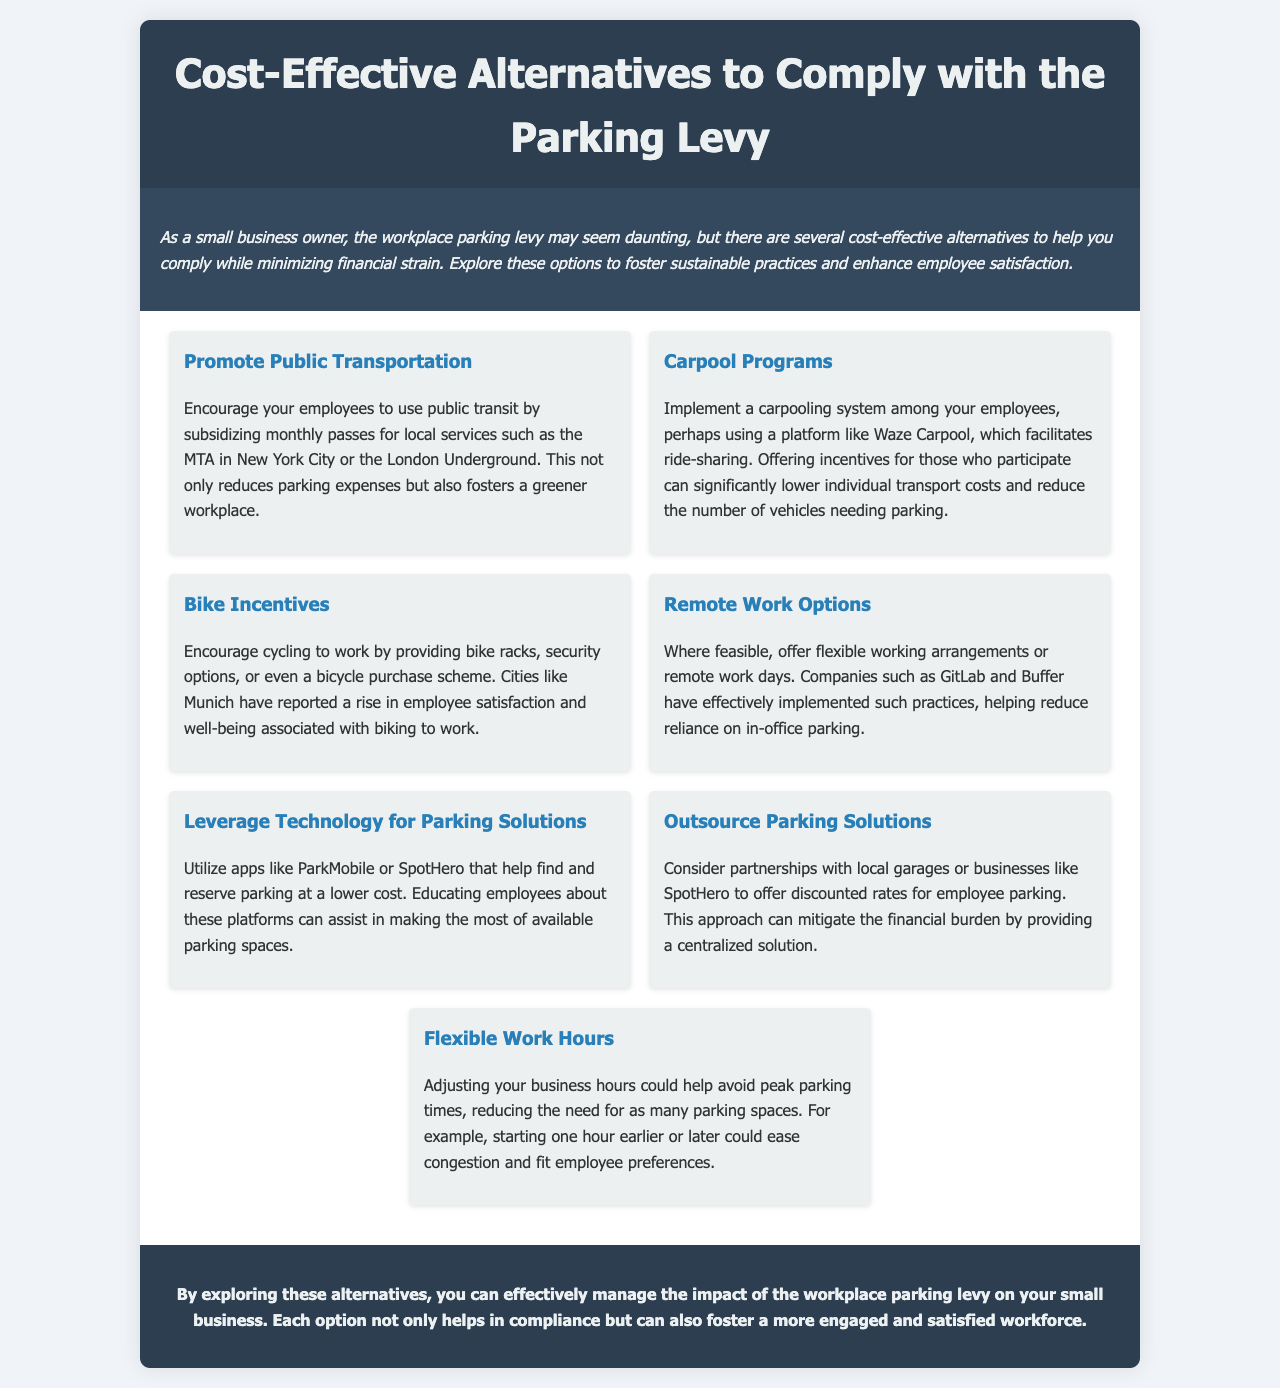What is the title of the brochure? The title is prominently displayed at the top of the document, identifying the key subject of the content.
Answer: Cost-Effective Alternatives to Comply with the Parking Levy Who is the target audience of the brochure? The introduction section specifies the intended audience for the brochure, thereby giving context to the content.
Answer: Small business owners What is one option to help reduce parking expenses? The document lists several strategies, one of which specifically addresses reducing individual transport costs.
Answer: Promote Public Transportation How can businesses implement carpooling? The document suggests using a specific platform that facilitates ride-sharing among employees.
Answer: Waze Carpool What is a suggested incentive to encourage cycling? The alternatives section discusses various ways to support cycling, one of which includes physical support at the business premises.
Answer: Bike racks Which company provides an example of effective remote work practices? This question refers to a specific company mentioned in the brochure as a successful case study in implementing flexible work options.
Answer: GitLab What is a technology-based solution for parking? The document outlines multiple options, one of which leverages mobile apps to assist with parking logistics.
Answer: ParkMobile What is one way to avoid peak parking times? The alternatives section suggests adjusting business operations to alleviate parking demands.
Answer: Flexible Work Hours 